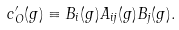<formula> <loc_0><loc_0><loc_500><loc_500>c _ { O } ^ { \prime } ( g ) \equiv B _ { i } ( g ) A _ { i j } ( g ) B _ { j } ( g ) .</formula> 